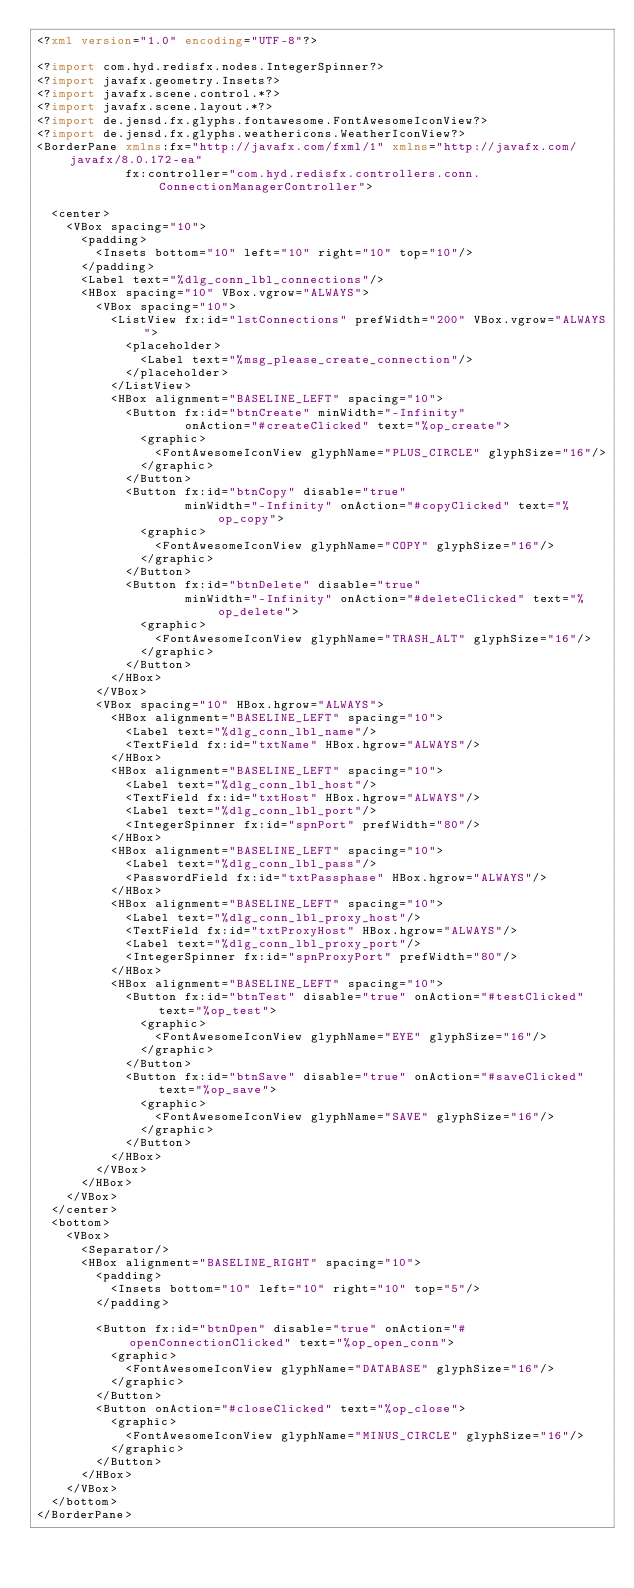<code> <loc_0><loc_0><loc_500><loc_500><_XML_><?xml version="1.0" encoding="UTF-8"?>

<?import com.hyd.redisfx.nodes.IntegerSpinner?>
<?import javafx.geometry.Insets?>
<?import javafx.scene.control.*?>
<?import javafx.scene.layout.*?>
<?import de.jensd.fx.glyphs.fontawesome.FontAwesomeIconView?>
<?import de.jensd.fx.glyphs.weathericons.WeatherIconView?>
<BorderPane xmlns:fx="http://javafx.com/fxml/1" xmlns="http://javafx.com/javafx/8.0.172-ea"
            fx:controller="com.hyd.redisfx.controllers.conn.ConnectionManagerController">

  <center>
    <VBox spacing="10">
      <padding>
        <Insets bottom="10" left="10" right="10" top="10"/>
      </padding>
      <Label text="%dlg_conn_lbl_connections"/>
      <HBox spacing="10" VBox.vgrow="ALWAYS">
        <VBox spacing="10">
          <ListView fx:id="lstConnections" prefWidth="200" VBox.vgrow="ALWAYS">
            <placeholder>
              <Label text="%msg_please_create_connection"/>
            </placeholder>
          </ListView>
          <HBox alignment="BASELINE_LEFT" spacing="10">
            <Button fx:id="btnCreate" minWidth="-Infinity"
                    onAction="#createClicked" text="%op_create">
              <graphic>
                <FontAwesomeIconView glyphName="PLUS_CIRCLE" glyphSize="16"/>
              </graphic>
            </Button>
            <Button fx:id="btnCopy" disable="true"
                    minWidth="-Infinity" onAction="#copyClicked" text="%op_copy">
              <graphic>
                <FontAwesomeIconView glyphName="COPY" glyphSize="16"/>
              </graphic>
            </Button>
            <Button fx:id="btnDelete" disable="true"
                    minWidth="-Infinity" onAction="#deleteClicked" text="%op_delete">
              <graphic>
                <FontAwesomeIconView glyphName="TRASH_ALT" glyphSize="16"/>
              </graphic>
            </Button>
          </HBox>
        </VBox>
        <VBox spacing="10" HBox.hgrow="ALWAYS">
          <HBox alignment="BASELINE_LEFT" spacing="10">
            <Label text="%dlg_conn_lbl_name"/>
            <TextField fx:id="txtName" HBox.hgrow="ALWAYS"/>
          </HBox>
          <HBox alignment="BASELINE_LEFT" spacing="10">
            <Label text="%dlg_conn_lbl_host"/>
            <TextField fx:id="txtHost" HBox.hgrow="ALWAYS"/>
            <Label text="%dlg_conn_lbl_port"/>
            <IntegerSpinner fx:id="spnPort" prefWidth="80"/>
          </HBox>
          <HBox alignment="BASELINE_LEFT" spacing="10">
            <Label text="%dlg_conn_lbl_pass"/>
            <PasswordField fx:id="txtPassphase" HBox.hgrow="ALWAYS"/>
          </HBox>
          <HBox alignment="BASELINE_LEFT" spacing="10">
            <Label text="%dlg_conn_lbl_proxy_host"/>
            <TextField fx:id="txtProxyHost" HBox.hgrow="ALWAYS"/>
            <Label text="%dlg_conn_lbl_proxy_port"/>
            <IntegerSpinner fx:id="spnProxyPort" prefWidth="80"/>
          </HBox>
          <HBox alignment="BASELINE_LEFT" spacing="10">
            <Button fx:id="btnTest" disable="true" onAction="#testClicked" text="%op_test">
              <graphic>
                <FontAwesomeIconView glyphName="EYE" glyphSize="16"/>
              </graphic>
            </Button>
            <Button fx:id="btnSave" disable="true" onAction="#saveClicked" text="%op_save">
              <graphic>
                <FontAwesomeIconView glyphName="SAVE" glyphSize="16"/>
              </graphic>
            </Button>
          </HBox>
        </VBox>
      </HBox>
    </VBox>
  </center>
  <bottom>
    <VBox>
      <Separator/>
      <HBox alignment="BASELINE_RIGHT" spacing="10">
        <padding>
          <Insets bottom="10" left="10" right="10" top="5"/>
        </padding>

        <Button fx:id="btnOpen" disable="true" onAction="#openConnectionClicked" text="%op_open_conn">
          <graphic>
            <FontAwesomeIconView glyphName="DATABASE" glyphSize="16"/>
          </graphic>
        </Button>
        <Button onAction="#closeClicked" text="%op_close">
          <graphic>
            <FontAwesomeIconView glyphName="MINUS_CIRCLE" glyphSize="16"/>
          </graphic>
        </Button>
      </HBox>
    </VBox>
  </bottom>
</BorderPane>
</code> 